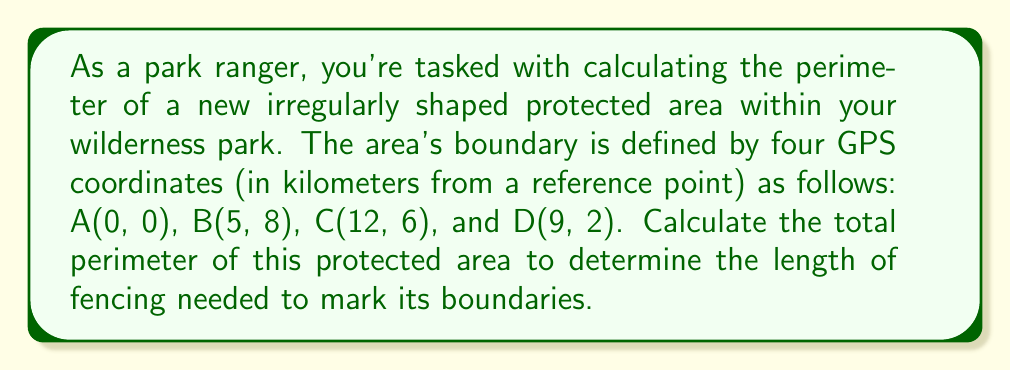Can you solve this math problem? To solve this problem, we'll use the distance formula between two points in a coordinate plane and sum up the distances between consecutive points to find the perimeter.

The distance formula between two points $(x_1, y_1)$ and $(x_2, y_2)$ is:

$$d = \sqrt{(x_2 - x_1)^2 + (y_2 - y_1)^2}$$

Let's calculate the distance for each side:

1. Side AB:
   $d_{AB} = \sqrt{(5-0)^2 + (8-0)^2} = \sqrt{25 + 64} = \sqrt{89}$ km

2. Side BC:
   $d_{BC} = \sqrt{(12-5)^2 + (6-8)^2} = \sqrt{49 + 4} = \sqrt{53}$ km

3. Side CD:
   $d_{CD} = \sqrt{(9-12)^2 + (2-6)^2} = \sqrt{9 + 16} = 5$ km

4. Side DA:
   $d_{DA} = \sqrt{(0-9)^2 + (0-2)^2} = \sqrt{81 + 4} = \sqrt{85}$ km

The total perimeter is the sum of these distances:

$$\text{Perimeter} = d_{AB} + d_{BC} + d_{CD} + d_{DA}$$
$$= \sqrt{89} + \sqrt{53} + 5 + \sqrt{85}$$

To simplify, we can leave the answer in this form or use a calculator to get an approximate value.

Using a calculator:
$$\approx 9.43 + 7.28 + 5 + 9.22 = 30.93\text{ km}$$

[asy]
unitsize(10mm);
pair A = (0,0), B = (5,8), C = (12,6), D = (9,2);
draw(A--B--C--D--cycle);
dot(A); dot(B); dot(C); dot(D);
label("A(0,0)", A, SW);
label("B(5,8)", B, NE);
label("C(12,6)", C, E);
label("D(9,2)", D, SE);
[/asy]
Answer: The perimeter of the protected area is $\sqrt{89} + \sqrt{53} + 5 + \sqrt{85}$ km, or approximately 30.93 km. 